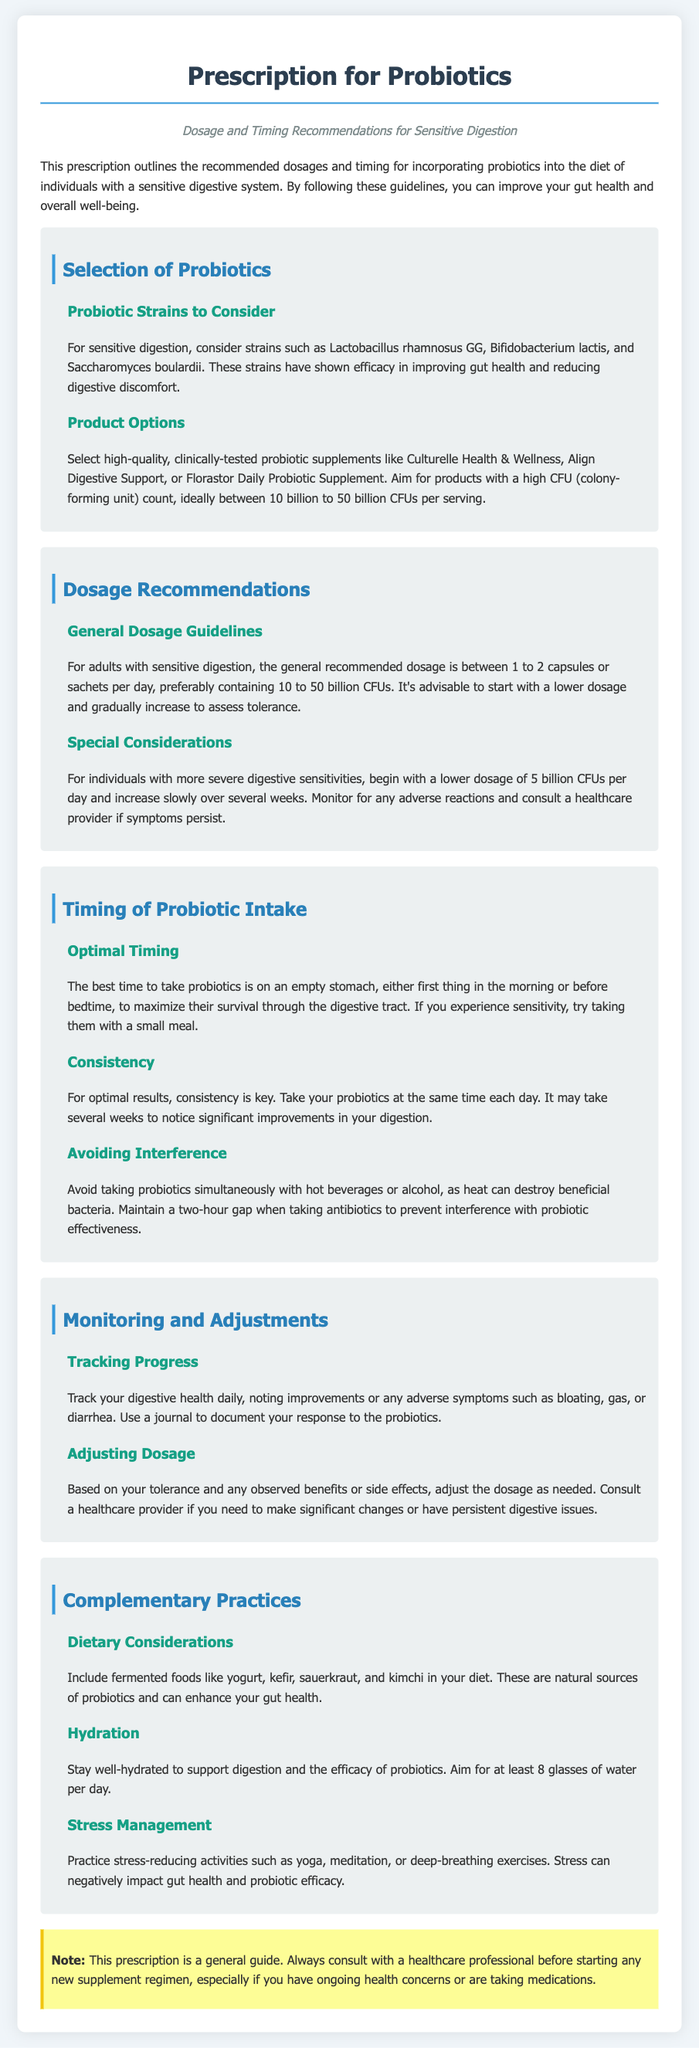What are the recommended probiotic strains for sensitive digestion? The document lists specific probiotic strains that are beneficial for sensitive digestion, focusing on their efficacy in improving gut health.
Answer: Lactobacillus rhamnosus GG, Bifidobacterium lactis, Saccharomyces boulardii What is the general recommended dosage for adults with sensitive digestion? There is a specified dosage range for adults with a sensitive digestive system in the document.
Answer: 1 to 2 capsules or sachets per day What is the optimal timing to take probiotics? The document emphasizes the best times to take probiotics for better efficacy based on digestive conditions.
Answer: On an empty stomach, first thing in the morning or before bedtime What is the preferred CFU count range for probiotic supplements? The document outlines an ideal CFU count for effective probiotic intake suitable for sensitive digestion.
Answer: 10 billion to 50 billion CFUs per serving What should be monitored when taking probiotics? The document suggests keeping track of specific symptoms or improvements while using probiotics for effective monitoring of digestive health.
Answer: Digestive health daily, noting improvements or any adverse symptoms What are complementary dietary practices recommended in the document? The document provides advice on dietary habits that support probiotic effectiveness and overall gut health.
Answer: Include fermented foods like yogurt, kefir, sauerkraut, and kimchi What should be avoided when taking probiotics? The document lists certain factors that may interfere with probiotic effectiveness that one should be aware of.
Answer: Hot beverages or alcohol What is the purpose of the note at the end of the document? The note provides crucial information regarding the use of the prescription and highlights the importance of consulting professionals.
Answer: Consult with a healthcare professional before starting any new supplement regimen 